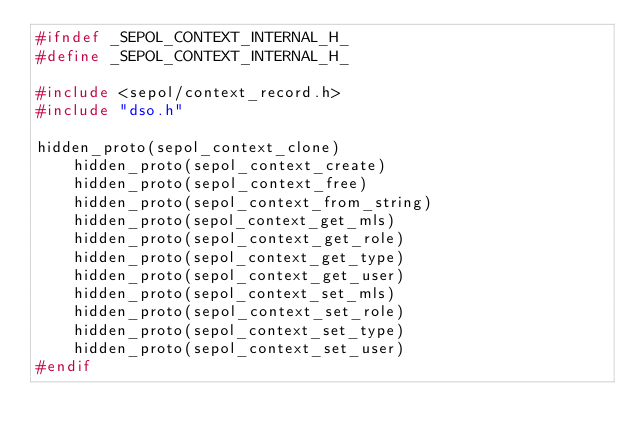Convert code to text. <code><loc_0><loc_0><loc_500><loc_500><_C_>#ifndef _SEPOL_CONTEXT_INTERNAL_H_
#define _SEPOL_CONTEXT_INTERNAL_H_

#include <sepol/context_record.h>
#include "dso.h"

hidden_proto(sepol_context_clone)
    hidden_proto(sepol_context_create)
    hidden_proto(sepol_context_free)
    hidden_proto(sepol_context_from_string)
    hidden_proto(sepol_context_get_mls)
    hidden_proto(sepol_context_get_role)
    hidden_proto(sepol_context_get_type)
    hidden_proto(sepol_context_get_user)
    hidden_proto(sepol_context_set_mls)
    hidden_proto(sepol_context_set_role)
    hidden_proto(sepol_context_set_type)
    hidden_proto(sepol_context_set_user)
#endif
</code> 